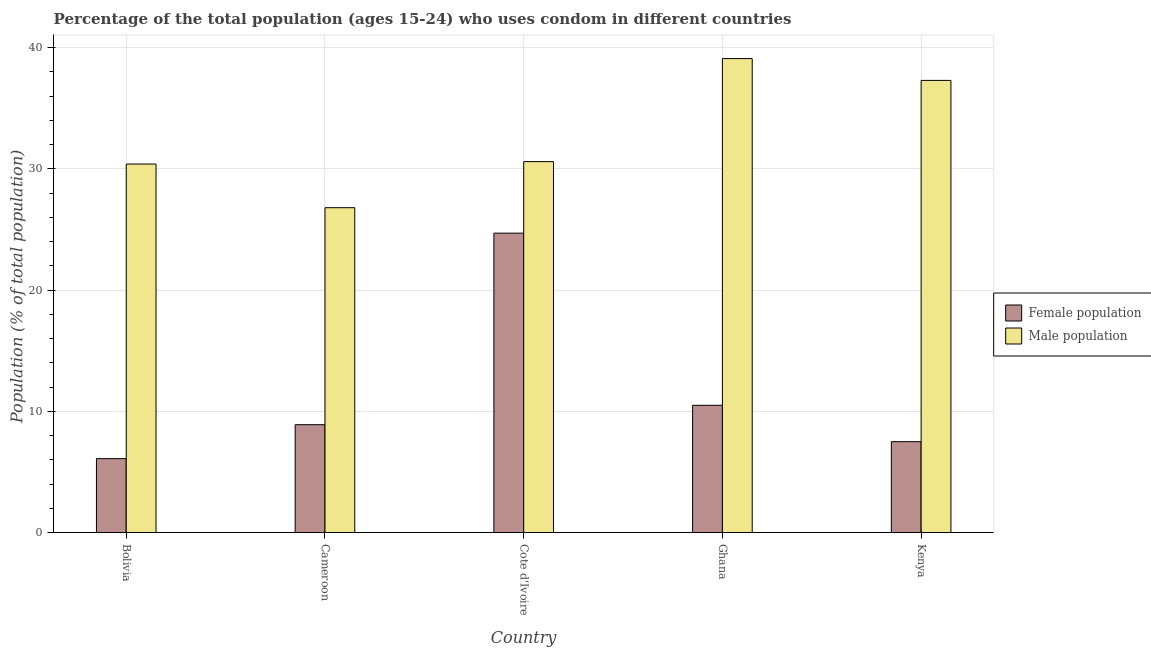How many groups of bars are there?
Make the answer very short. 5. Are the number of bars per tick equal to the number of legend labels?
Your answer should be very brief. Yes. How many bars are there on the 4th tick from the left?
Keep it short and to the point. 2. How many bars are there on the 2nd tick from the right?
Offer a terse response. 2. What is the label of the 4th group of bars from the left?
Give a very brief answer. Ghana. In how many cases, is the number of bars for a given country not equal to the number of legend labels?
Ensure brevity in your answer.  0. What is the male population in Ghana?
Your answer should be compact. 39.1. Across all countries, what is the maximum female population?
Provide a short and direct response. 24.7. Across all countries, what is the minimum female population?
Ensure brevity in your answer.  6.1. In which country was the male population maximum?
Give a very brief answer. Ghana. In which country was the male population minimum?
Your response must be concise. Cameroon. What is the total male population in the graph?
Provide a short and direct response. 164.2. What is the difference between the male population in Kenya and the female population in Bolivia?
Your answer should be compact. 31.2. What is the average female population per country?
Offer a very short reply. 11.54. What is the difference between the female population and male population in Kenya?
Give a very brief answer. -29.8. In how many countries, is the male population greater than 22 %?
Provide a short and direct response. 5. What is the ratio of the female population in Bolivia to that in Cote d'Ivoire?
Offer a terse response. 0.25. Is the difference between the female population in Cameroon and Ghana greater than the difference between the male population in Cameroon and Ghana?
Ensure brevity in your answer.  Yes. What is the difference between the highest and the second highest female population?
Keep it short and to the point. 14.2. In how many countries, is the female population greater than the average female population taken over all countries?
Make the answer very short. 1. Is the sum of the male population in Bolivia and Cameroon greater than the maximum female population across all countries?
Your response must be concise. Yes. What does the 1st bar from the left in Cote d'Ivoire represents?
Your answer should be very brief. Female population. What does the 1st bar from the right in Kenya represents?
Your response must be concise. Male population. Does the graph contain any zero values?
Your answer should be compact. No. Where does the legend appear in the graph?
Give a very brief answer. Center right. How are the legend labels stacked?
Make the answer very short. Vertical. What is the title of the graph?
Offer a very short reply. Percentage of the total population (ages 15-24) who uses condom in different countries. Does "Females" appear as one of the legend labels in the graph?
Your answer should be very brief. No. What is the label or title of the Y-axis?
Keep it short and to the point. Population (% of total population) . What is the Population (% of total population)  in Male population in Bolivia?
Provide a short and direct response. 30.4. What is the Population (% of total population)  of Male population in Cameroon?
Ensure brevity in your answer.  26.8. What is the Population (% of total population)  of Female population in Cote d'Ivoire?
Your response must be concise. 24.7. What is the Population (% of total population)  in Male population in Cote d'Ivoire?
Your answer should be compact. 30.6. What is the Population (% of total population)  of Male population in Ghana?
Ensure brevity in your answer.  39.1. What is the Population (% of total population)  of Male population in Kenya?
Keep it short and to the point. 37.3. Across all countries, what is the maximum Population (% of total population)  of Female population?
Your response must be concise. 24.7. Across all countries, what is the maximum Population (% of total population)  of Male population?
Ensure brevity in your answer.  39.1. Across all countries, what is the minimum Population (% of total population)  in Female population?
Provide a succinct answer. 6.1. Across all countries, what is the minimum Population (% of total population)  in Male population?
Provide a succinct answer. 26.8. What is the total Population (% of total population)  in Female population in the graph?
Offer a very short reply. 57.7. What is the total Population (% of total population)  of Male population in the graph?
Offer a very short reply. 164.2. What is the difference between the Population (% of total population)  of Female population in Bolivia and that in Cameroon?
Provide a short and direct response. -2.8. What is the difference between the Population (% of total population)  of Male population in Bolivia and that in Cameroon?
Your answer should be very brief. 3.6. What is the difference between the Population (% of total population)  of Female population in Bolivia and that in Cote d'Ivoire?
Ensure brevity in your answer.  -18.6. What is the difference between the Population (% of total population)  of Female population in Bolivia and that in Ghana?
Your answer should be compact. -4.4. What is the difference between the Population (% of total population)  of Male population in Bolivia and that in Ghana?
Provide a short and direct response. -8.7. What is the difference between the Population (% of total population)  in Female population in Bolivia and that in Kenya?
Keep it short and to the point. -1.4. What is the difference between the Population (% of total population)  in Female population in Cameroon and that in Cote d'Ivoire?
Offer a terse response. -15.8. What is the difference between the Population (% of total population)  in Male population in Cameroon and that in Cote d'Ivoire?
Provide a short and direct response. -3.8. What is the difference between the Population (% of total population)  of Male population in Cameroon and that in Ghana?
Offer a terse response. -12.3. What is the difference between the Population (% of total population)  in Female population in Cameroon and that in Kenya?
Your answer should be very brief. 1.4. What is the difference between the Population (% of total population)  in Male population in Cameroon and that in Kenya?
Ensure brevity in your answer.  -10.5. What is the difference between the Population (% of total population)  of Female population in Cote d'Ivoire and that in Ghana?
Keep it short and to the point. 14.2. What is the difference between the Population (% of total population)  of Male population in Cote d'Ivoire and that in Ghana?
Your answer should be compact. -8.5. What is the difference between the Population (% of total population)  in Female population in Cote d'Ivoire and that in Kenya?
Offer a terse response. 17.2. What is the difference between the Population (% of total population)  of Female population in Ghana and that in Kenya?
Keep it short and to the point. 3. What is the difference between the Population (% of total population)  in Male population in Ghana and that in Kenya?
Ensure brevity in your answer.  1.8. What is the difference between the Population (% of total population)  of Female population in Bolivia and the Population (% of total population)  of Male population in Cameroon?
Your answer should be compact. -20.7. What is the difference between the Population (% of total population)  of Female population in Bolivia and the Population (% of total population)  of Male population in Cote d'Ivoire?
Your response must be concise. -24.5. What is the difference between the Population (% of total population)  in Female population in Bolivia and the Population (% of total population)  in Male population in Ghana?
Your answer should be very brief. -33. What is the difference between the Population (% of total population)  of Female population in Bolivia and the Population (% of total population)  of Male population in Kenya?
Provide a short and direct response. -31.2. What is the difference between the Population (% of total population)  in Female population in Cameroon and the Population (% of total population)  in Male population in Cote d'Ivoire?
Your answer should be compact. -21.7. What is the difference between the Population (% of total population)  of Female population in Cameroon and the Population (% of total population)  of Male population in Ghana?
Your response must be concise. -30.2. What is the difference between the Population (% of total population)  of Female population in Cameroon and the Population (% of total population)  of Male population in Kenya?
Give a very brief answer. -28.4. What is the difference between the Population (% of total population)  in Female population in Cote d'Ivoire and the Population (% of total population)  in Male population in Ghana?
Keep it short and to the point. -14.4. What is the difference between the Population (% of total population)  in Female population in Cote d'Ivoire and the Population (% of total population)  in Male population in Kenya?
Offer a very short reply. -12.6. What is the difference between the Population (% of total population)  of Female population in Ghana and the Population (% of total population)  of Male population in Kenya?
Offer a very short reply. -26.8. What is the average Population (% of total population)  in Female population per country?
Ensure brevity in your answer.  11.54. What is the average Population (% of total population)  in Male population per country?
Your response must be concise. 32.84. What is the difference between the Population (% of total population)  of Female population and Population (% of total population)  of Male population in Bolivia?
Ensure brevity in your answer.  -24.3. What is the difference between the Population (% of total population)  of Female population and Population (% of total population)  of Male population in Cameroon?
Your answer should be compact. -17.9. What is the difference between the Population (% of total population)  of Female population and Population (% of total population)  of Male population in Ghana?
Provide a short and direct response. -28.6. What is the difference between the Population (% of total population)  of Female population and Population (% of total population)  of Male population in Kenya?
Offer a terse response. -29.8. What is the ratio of the Population (% of total population)  in Female population in Bolivia to that in Cameroon?
Ensure brevity in your answer.  0.69. What is the ratio of the Population (% of total population)  in Male population in Bolivia to that in Cameroon?
Keep it short and to the point. 1.13. What is the ratio of the Population (% of total population)  of Female population in Bolivia to that in Cote d'Ivoire?
Your answer should be compact. 0.25. What is the ratio of the Population (% of total population)  in Female population in Bolivia to that in Ghana?
Your answer should be very brief. 0.58. What is the ratio of the Population (% of total population)  in Male population in Bolivia to that in Ghana?
Ensure brevity in your answer.  0.78. What is the ratio of the Population (% of total population)  of Female population in Bolivia to that in Kenya?
Make the answer very short. 0.81. What is the ratio of the Population (% of total population)  in Male population in Bolivia to that in Kenya?
Provide a succinct answer. 0.81. What is the ratio of the Population (% of total population)  of Female population in Cameroon to that in Cote d'Ivoire?
Provide a succinct answer. 0.36. What is the ratio of the Population (% of total population)  of Male population in Cameroon to that in Cote d'Ivoire?
Your answer should be very brief. 0.88. What is the ratio of the Population (% of total population)  in Female population in Cameroon to that in Ghana?
Keep it short and to the point. 0.85. What is the ratio of the Population (% of total population)  of Male population in Cameroon to that in Ghana?
Provide a short and direct response. 0.69. What is the ratio of the Population (% of total population)  in Female population in Cameroon to that in Kenya?
Your answer should be very brief. 1.19. What is the ratio of the Population (% of total population)  in Male population in Cameroon to that in Kenya?
Provide a short and direct response. 0.72. What is the ratio of the Population (% of total population)  of Female population in Cote d'Ivoire to that in Ghana?
Make the answer very short. 2.35. What is the ratio of the Population (% of total population)  in Male population in Cote d'Ivoire to that in Ghana?
Provide a succinct answer. 0.78. What is the ratio of the Population (% of total population)  in Female population in Cote d'Ivoire to that in Kenya?
Give a very brief answer. 3.29. What is the ratio of the Population (% of total population)  in Male population in Cote d'Ivoire to that in Kenya?
Keep it short and to the point. 0.82. What is the ratio of the Population (% of total population)  of Male population in Ghana to that in Kenya?
Your answer should be very brief. 1.05. What is the difference between the highest and the second highest Population (% of total population)  of Female population?
Your answer should be compact. 14.2. What is the difference between the highest and the lowest Population (% of total population)  in Female population?
Give a very brief answer. 18.6. 